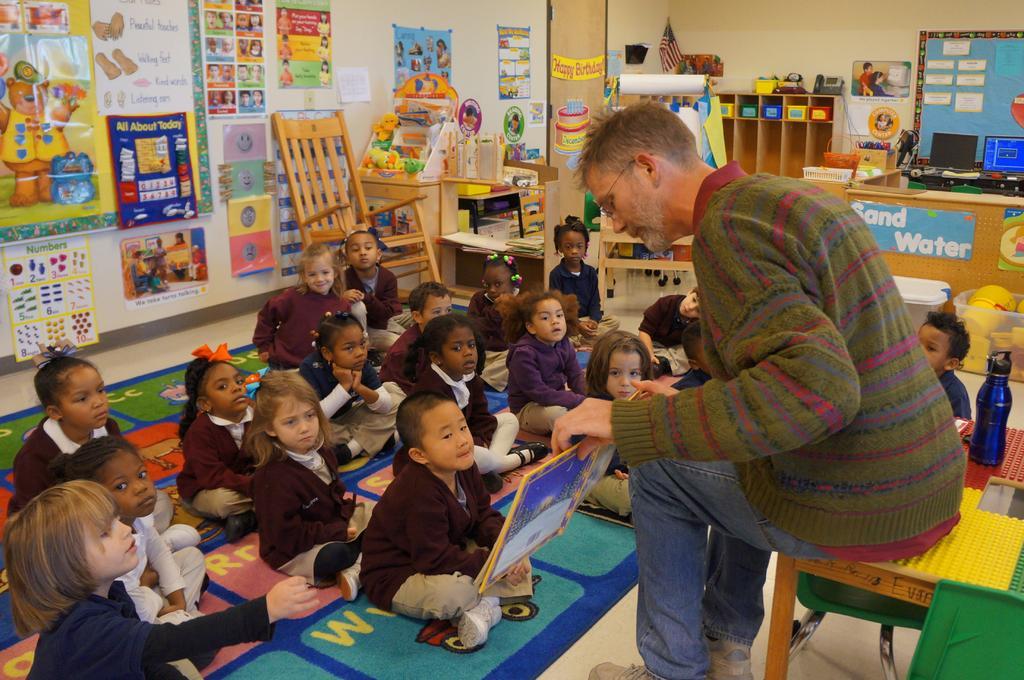Describe this image in one or two sentences. In this picture we can see boys and girls sitting on a floor. We can see this man sitting on a chair and holding a book in his hand and teaching. He wore spectacles. We can see posts over a wall. These are cupboards. We can see computers here. This is a bottle. 